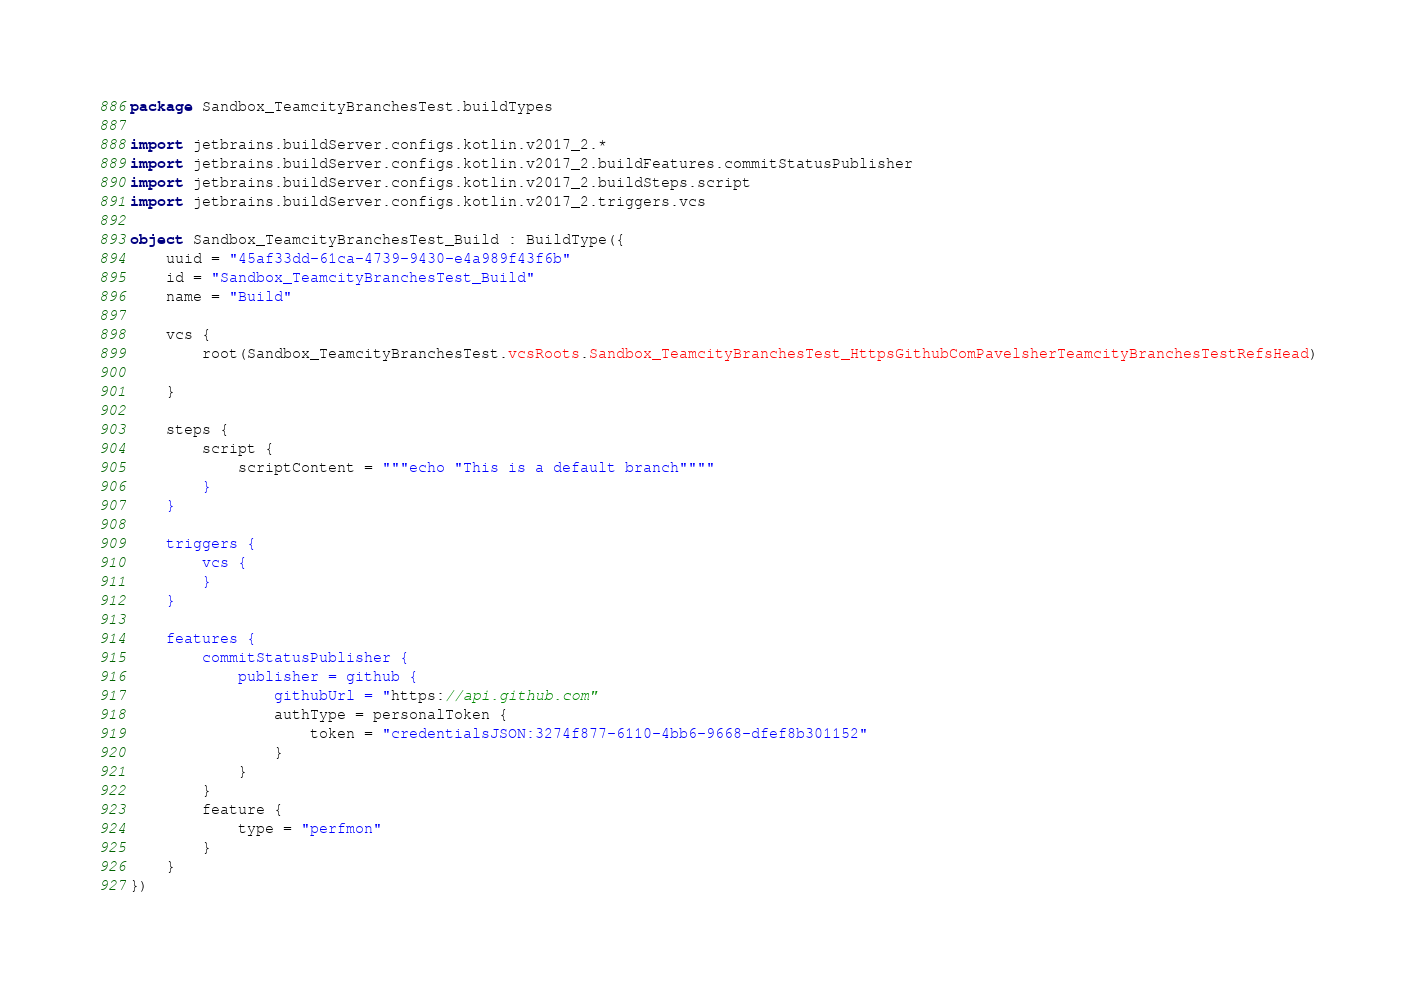<code> <loc_0><loc_0><loc_500><loc_500><_Kotlin_>package Sandbox_TeamcityBranchesTest.buildTypes

import jetbrains.buildServer.configs.kotlin.v2017_2.*
import jetbrains.buildServer.configs.kotlin.v2017_2.buildFeatures.commitStatusPublisher
import jetbrains.buildServer.configs.kotlin.v2017_2.buildSteps.script
import jetbrains.buildServer.configs.kotlin.v2017_2.triggers.vcs

object Sandbox_TeamcityBranchesTest_Build : BuildType({
    uuid = "45af33dd-61ca-4739-9430-e4a989f43f6b"
    id = "Sandbox_TeamcityBranchesTest_Build"
    name = "Build"

    vcs {
        root(Sandbox_TeamcityBranchesTest.vcsRoots.Sandbox_TeamcityBranchesTest_HttpsGithubComPavelsherTeamcityBranchesTestRefsHead)

    }

    steps {
        script {
            scriptContent = """echo "This is a default branch""""
        }
    }

    triggers {
        vcs {
        }
    }

    features {
        commitStatusPublisher {
            publisher = github {
                githubUrl = "https://api.github.com"
                authType = personalToken {
                    token = "credentialsJSON:3274f877-6110-4bb6-9668-dfef8b301152"
                }
            }
        }
        feature {
            type = "perfmon"
        }
    }
})
</code> 